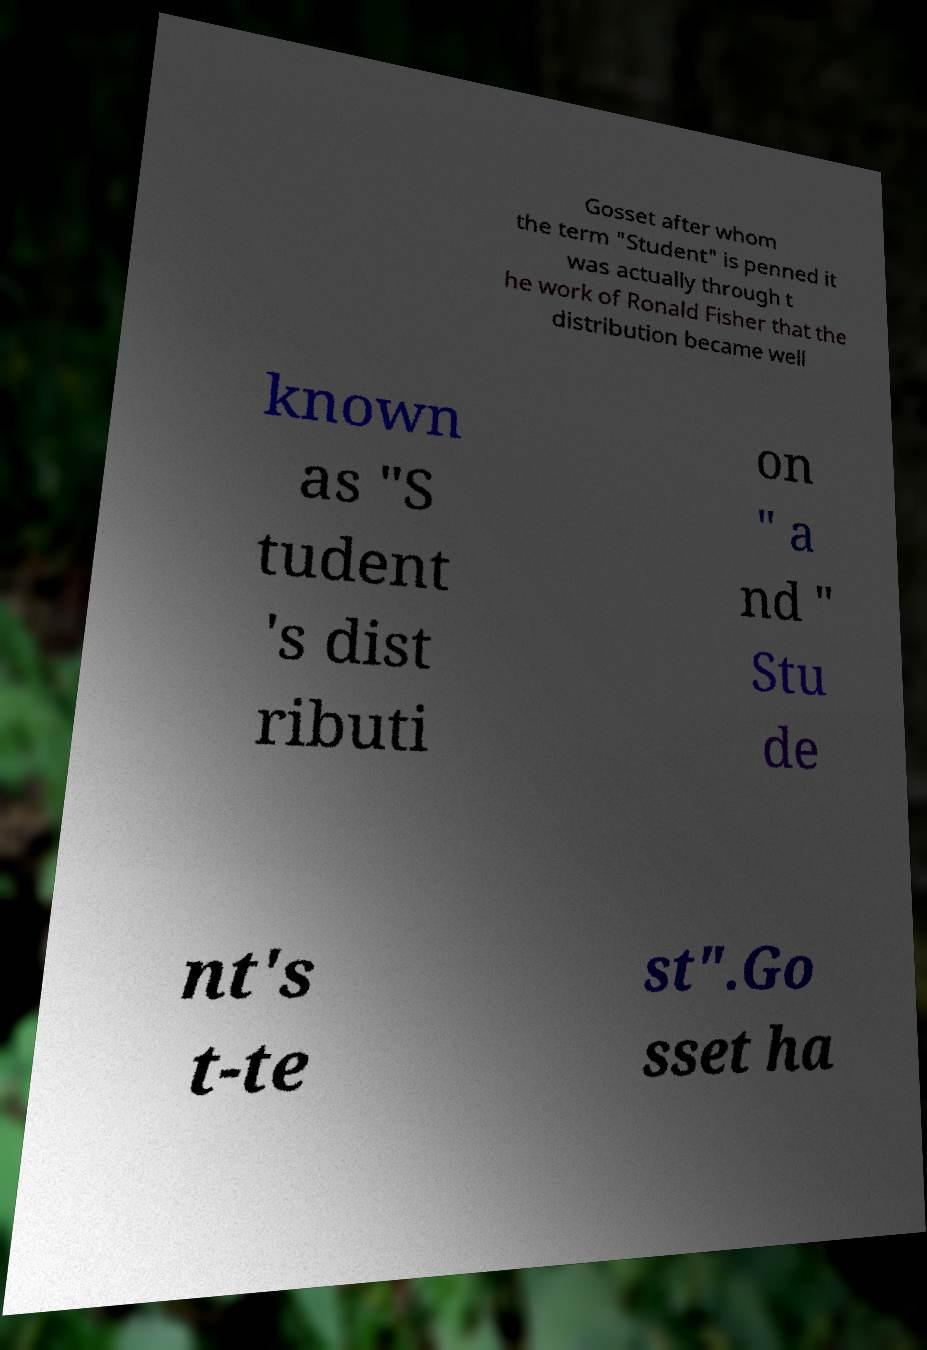There's text embedded in this image that I need extracted. Can you transcribe it verbatim? Gosset after whom the term "Student" is penned it was actually through t he work of Ronald Fisher that the distribution became well known as "S tudent 's dist ributi on " a nd " Stu de nt's t-te st".Go sset ha 